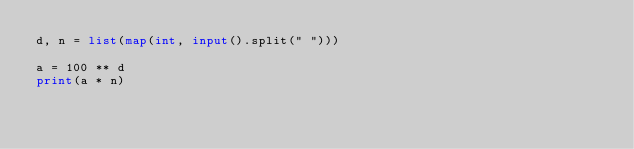<code> <loc_0><loc_0><loc_500><loc_500><_Python_>d, n = list(map(int, input().split(" ")))

a = 100 ** d
print(a * n)</code> 